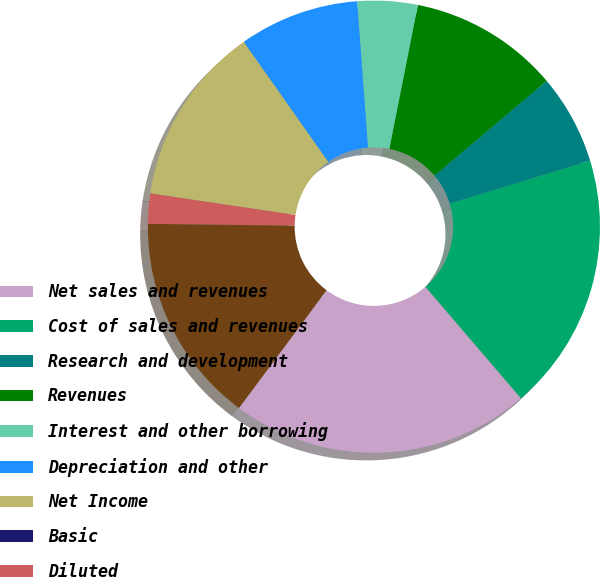<chart> <loc_0><loc_0><loc_500><loc_500><pie_chart><fcel>Net sales and revenues<fcel>Cost of sales and revenues<fcel>Research and development<fcel>Revenues<fcel>Interest and other borrowing<fcel>Depreciation and other<fcel>Net Income<fcel>Basic<fcel>Diluted<fcel>Net (Loss) Income<nl><fcel>21.46%<fcel>18.44%<fcel>6.44%<fcel>10.73%<fcel>4.3%<fcel>8.59%<fcel>12.88%<fcel>0.0%<fcel>2.15%<fcel>15.02%<nl></chart> 